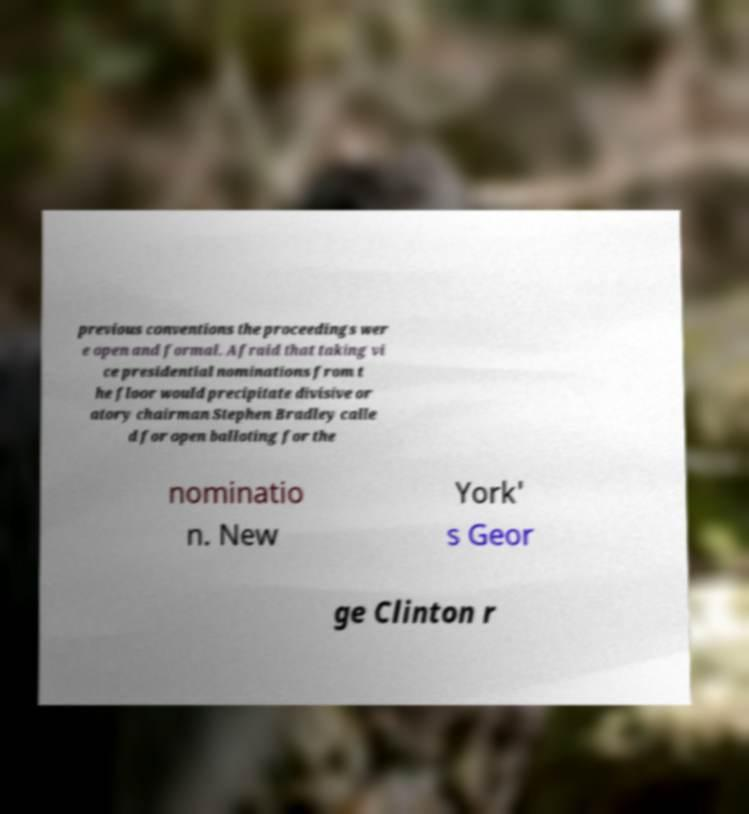Could you assist in decoding the text presented in this image and type it out clearly? previous conventions the proceedings wer e open and formal. Afraid that taking vi ce presidential nominations from t he floor would precipitate divisive or atory chairman Stephen Bradley calle d for open balloting for the nominatio n. New York' s Geor ge Clinton r 